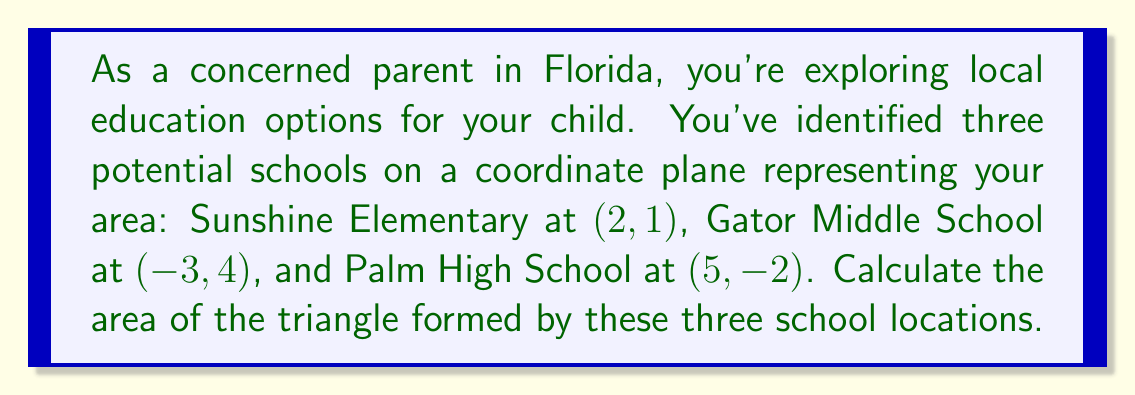Provide a solution to this math problem. To find the area of a triangle given the coordinates of its vertices, we can use the formula:

$$\text{Area} = \frac{1}{2}|x_1(y_2 - y_3) + x_2(y_3 - y_1) + x_3(y_1 - y_2)|$$

Where $(x_1, y_1)$, $(x_2, y_2)$, and $(x_3, y_3)$ are the coordinates of the three vertices.

Let's assign our points:
$(x_1, y_1) = (2, 1)$ for Sunshine Elementary
$(x_2, y_2) = (-3, 4)$ for Gator Middle School
$(x_3, y_3) = (5, -2)$ for Palm High School

Now, let's substitute these values into our formula:

$$\begin{align*}
\text{Area} &= \frac{1}{2}|2(4 - (-2)) + (-3)((-2) - 1) + 5(1 - 4)|\\
&= \frac{1}{2}|2(6) + (-3)(-3) + 5(-3)|\\
&= \frac{1}{2}|12 + 9 - 15|\\
&= \frac{1}{2}|6|\\
&= \frac{1}{2}(6)\\
&= 3
\end{align*}$$

The absolute value is used in the formula to ensure a positive area, regardless of the order in which we list the vertices.

[asy]
unitsize(20);
dot((2,1));
dot((-3,4));
dot((5,-2));
draw((2,1)--(-3,4)--(5,-2)--cycle);
label("Sunshine Elementary (2,1)", (2,1), NE);
label("Gator Middle School (-3,4)", (-3,4), NW);
label("Palm High School (5,-2)", (5,-2), SE);
[/asy]
Answer: The area of the triangle formed by the three school locations is 3 square units. 